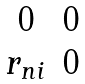Convert formula to latex. <formula><loc_0><loc_0><loc_500><loc_500>\begin{matrix} 0 & 0 \\ r _ { n i } & 0 \end{matrix}</formula> 